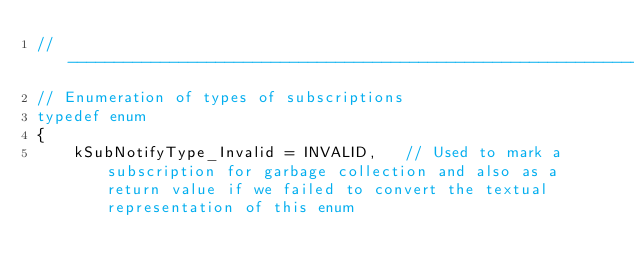<code> <loc_0><loc_0><loc_500><loc_500><_C_>//------------------------------------------------------------------------------
// Enumeration of types of subscriptions
typedef enum
{
    kSubNotifyType_Invalid = INVALID,   // Used to mark a subscription for garbage collection and also as a return value if we failed to convert the textual representation of this enum</code> 